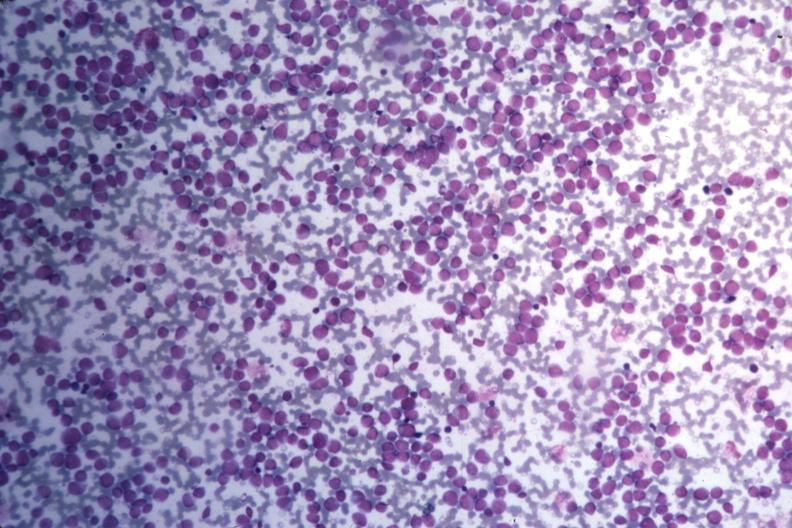s bone marrow present?
Answer the question using a single word or phrase. Yes 